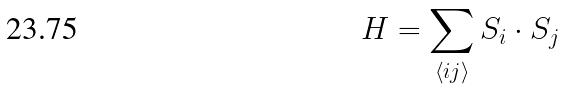Convert formula to latex. <formula><loc_0><loc_0><loc_500><loc_500>H = \sum _ { \left \langle i j \right \rangle } { S } _ { i } \cdot { S } _ { j }</formula> 